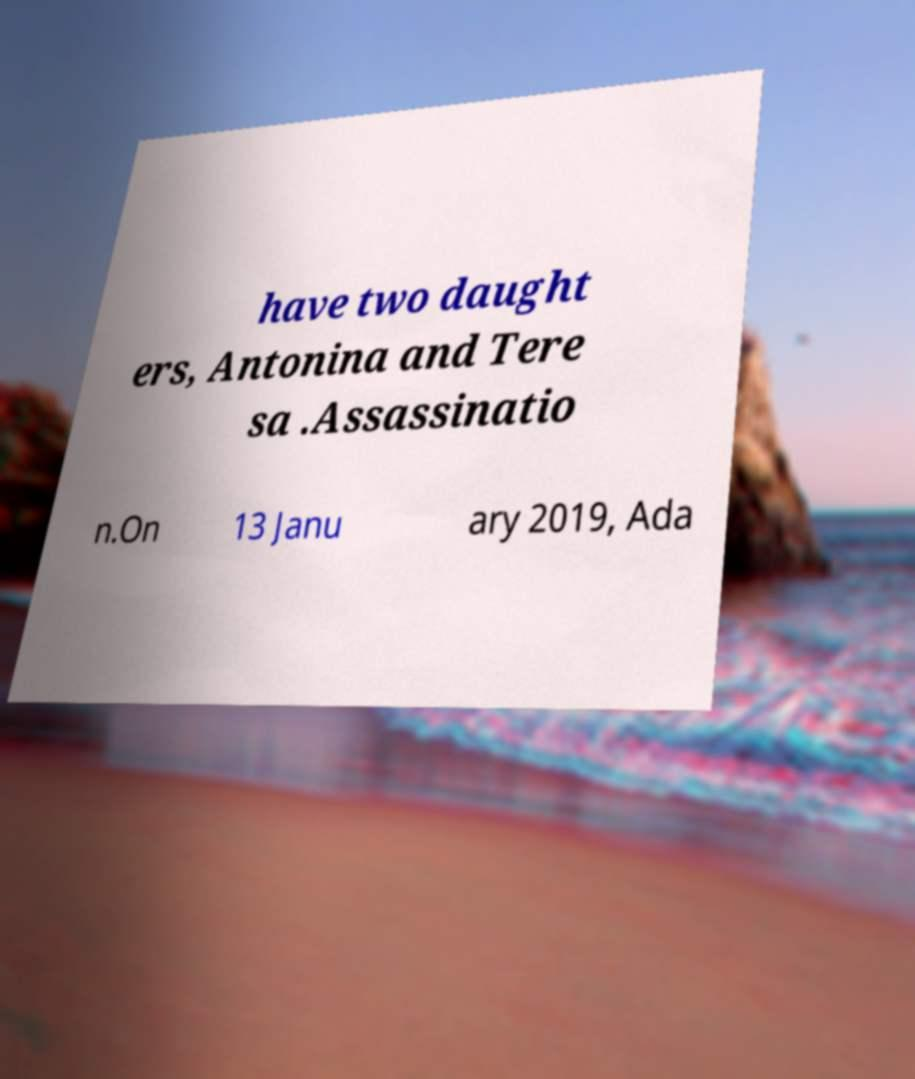Can you accurately transcribe the text from the provided image for me? have two daught ers, Antonina and Tere sa .Assassinatio n.On 13 Janu ary 2019, Ada 